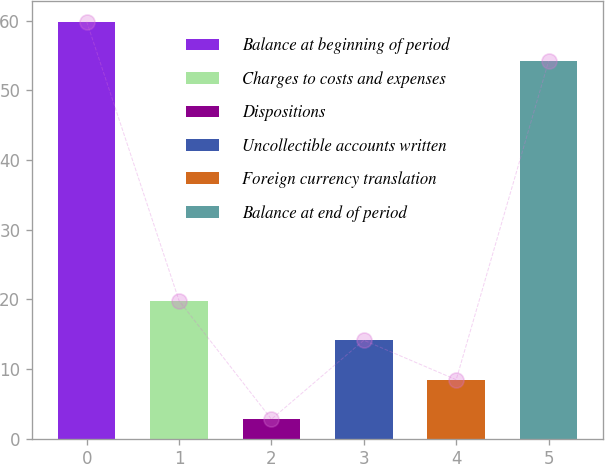Convert chart to OTSL. <chart><loc_0><loc_0><loc_500><loc_500><bar_chart><fcel>Balance at beginning of period<fcel>Charges to costs and expenses<fcel>Dispositions<fcel>Uncollectible accounts written<fcel>Foreign currency translation<fcel>Balance at end of period<nl><fcel>59.87<fcel>19.81<fcel>2.8<fcel>14.14<fcel>8.47<fcel>54.2<nl></chart> 